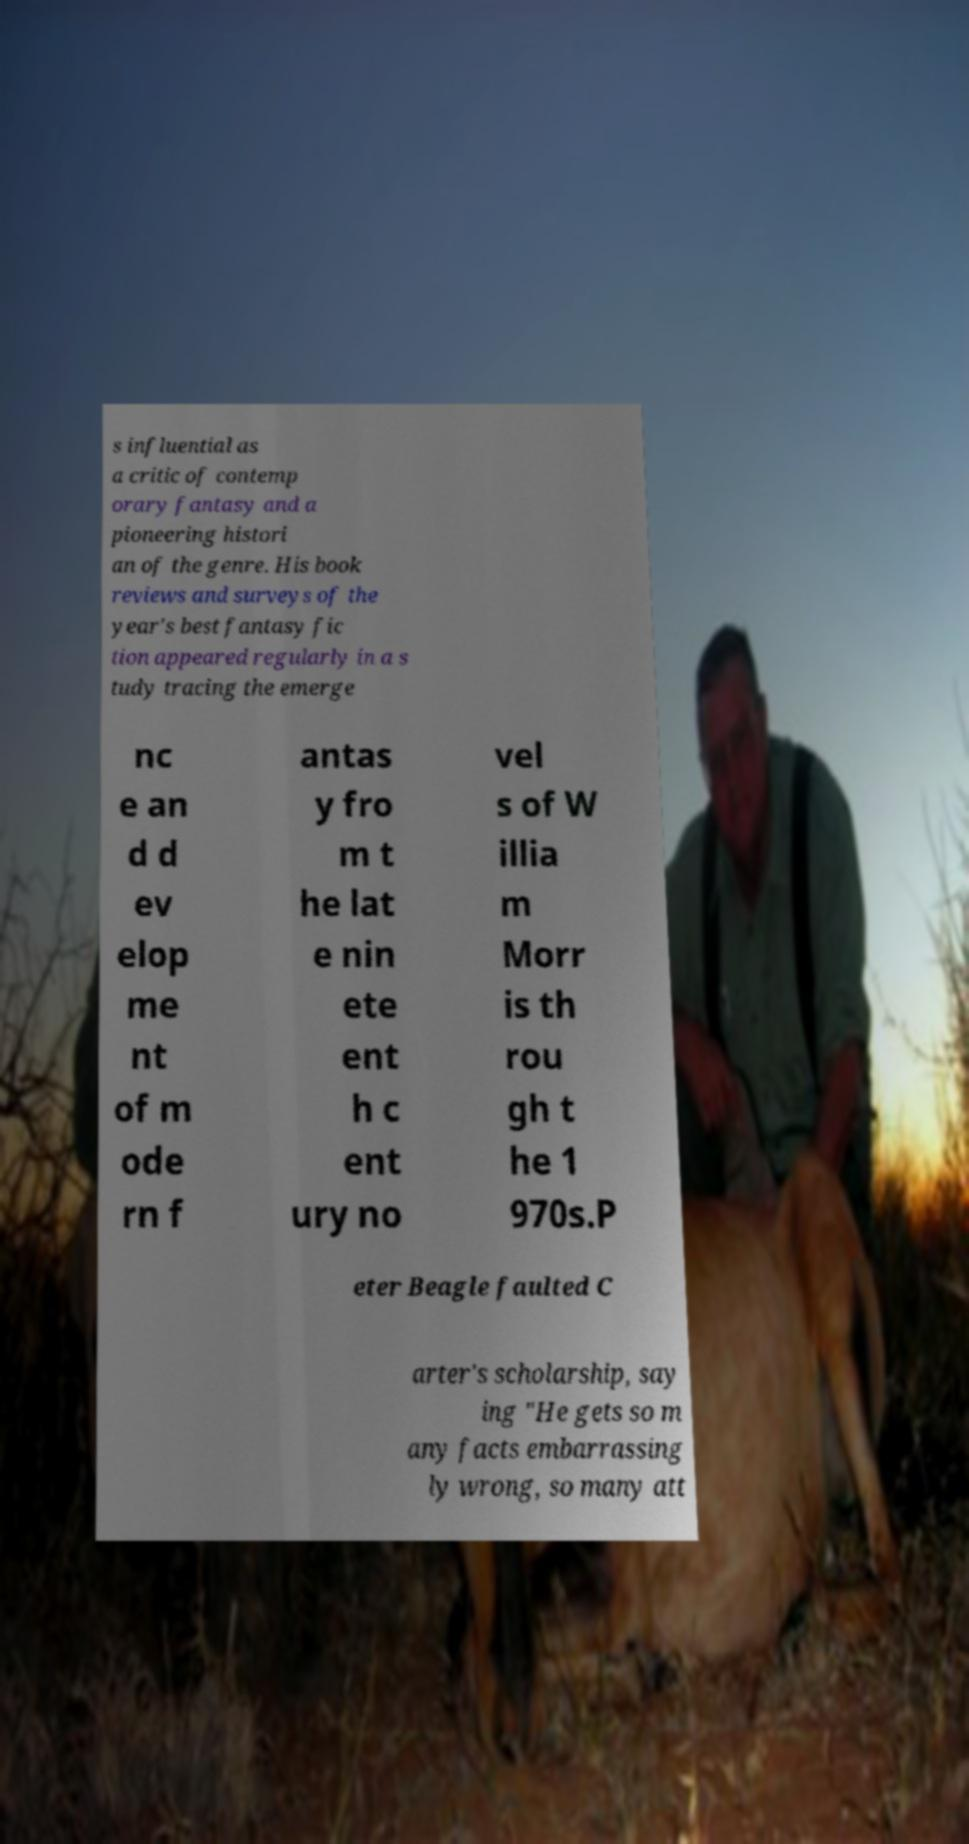Could you extract and type out the text from this image? s influential as a critic of contemp orary fantasy and a pioneering histori an of the genre. His book reviews and surveys of the year's best fantasy fic tion appeared regularly in a s tudy tracing the emerge nc e an d d ev elop me nt of m ode rn f antas y fro m t he lat e nin ete ent h c ent ury no vel s of W illia m Morr is th rou gh t he 1 970s.P eter Beagle faulted C arter's scholarship, say ing "He gets so m any facts embarrassing ly wrong, so many att 